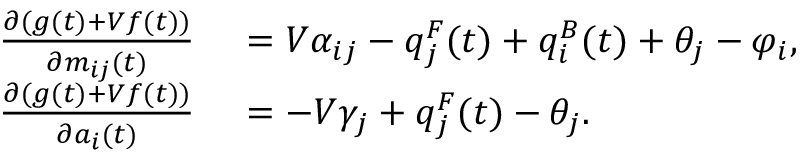<formula> <loc_0><loc_0><loc_500><loc_500>\begin{array} { r l } { \frac { \partial ( g ( t ) + V f ( t ) ) } { \partial m _ { i j } ( t ) } } & { = V \alpha _ { i j } - q _ { j } ^ { F } ( t ) + q _ { i } ^ { B } ( t ) + \theta _ { j } - \varphi _ { i } , } \\ { \frac { \partial ( g ( t ) + V f ( t ) ) } { \partial a _ { i } ( t ) } } & { = - V \gamma _ { j } + q _ { j } ^ { F } ( t ) - \theta _ { j } . } \end{array}</formula> 